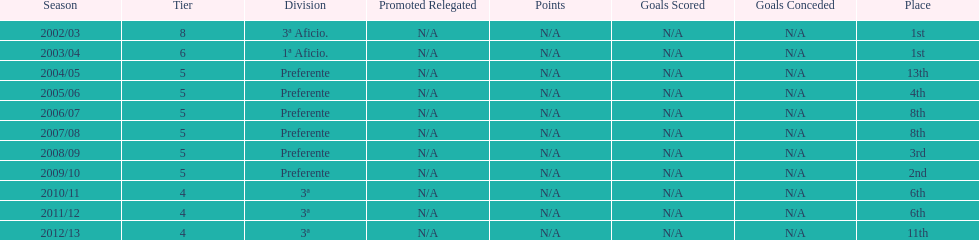How many seasons did internacional de madrid cf play in the preferente division? 6. I'm looking to parse the entire table for insights. Could you assist me with that? {'header': ['Season', 'Tier', 'Division', 'Promoted Relegated', 'Points', 'Goals Scored', 'Goals Conceded', 'Place'], 'rows': [['2002/03', '8', '3ª Aficio.', 'N/A', 'N/A', 'N/A', 'N/A', '1st'], ['2003/04', '6', '1ª Aficio.', 'N/A', 'N/A', 'N/A', 'N/A', '1st'], ['2004/05', '5', 'Preferente', 'N/A', 'N/A', 'N/A', 'N/A', '13th'], ['2005/06', '5', 'Preferente', 'N/A', 'N/A', 'N/A', 'N/A', '4th'], ['2006/07', '5', 'Preferente', 'N/A', 'N/A', 'N/A', 'N/A', '8th'], ['2007/08', '5', 'Preferente', 'N/A', 'N/A', 'N/A', 'N/A', '8th'], ['2008/09', '5', 'Preferente', 'N/A', 'N/A', 'N/A', 'N/A', '3rd'], ['2009/10', '5', 'Preferente', 'N/A', 'N/A', 'N/A', 'N/A', '2nd'], ['2010/11', '4', '3ª', 'N/A', 'N/A', 'N/A', 'N/A', '6th'], ['2011/12', '4', '3ª', 'N/A', 'N/A', 'N/A', 'N/A', '6th'], ['2012/13', '4', '3ª', 'N/A', 'N/A', 'N/A', 'N/A', '11th']]} 